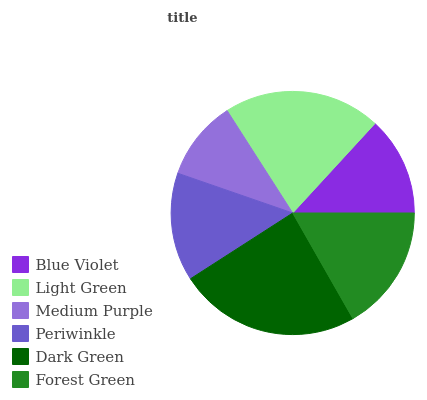Is Medium Purple the minimum?
Answer yes or no. Yes. Is Dark Green the maximum?
Answer yes or no. Yes. Is Light Green the minimum?
Answer yes or no. No. Is Light Green the maximum?
Answer yes or no. No. Is Light Green greater than Blue Violet?
Answer yes or no. Yes. Is Blue Violet less than Light Green?
Answer yes or no. Yes. Is Blue Violet greater than Light Green?
Answer yes or no. No. Is Light Green less than Blue Violet?
Answer yes or no. No. Is Forest Green the high median?
Answer yes or no. Yes. Is Periwinkle the low median?
Answer yes or no. Yes. Is Dark Green the high median?
Answer yes or no. No. Is Light Green the low median?
Answer yes or no. No. 